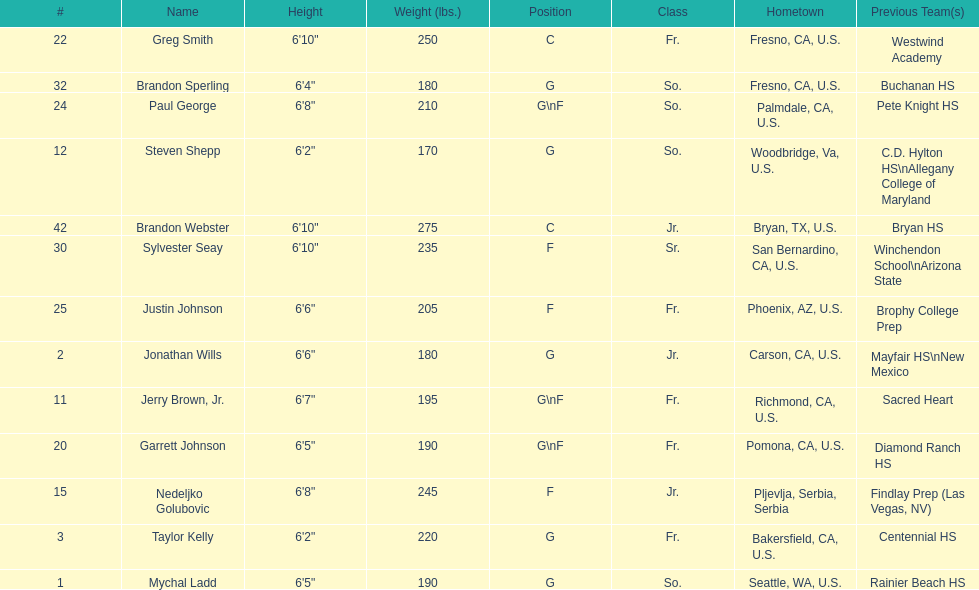Who is the only competitor not originating from the u.s.? Nedeljko Golubovic. 